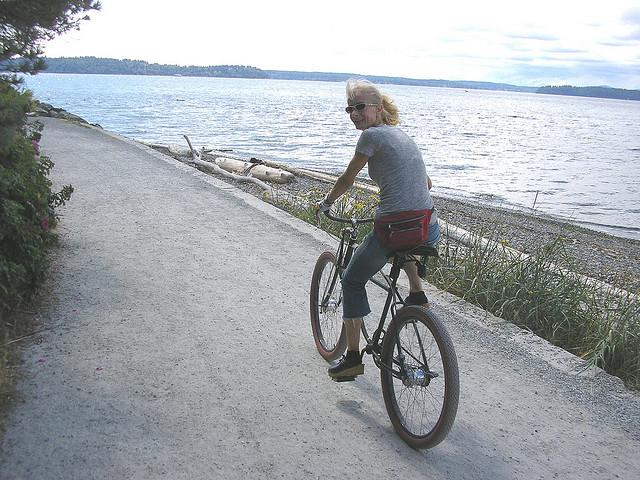Which wrong furnishing has the woman put on? Please explain your reasoning. shoes. The woman is wearing block heels to cycle. 